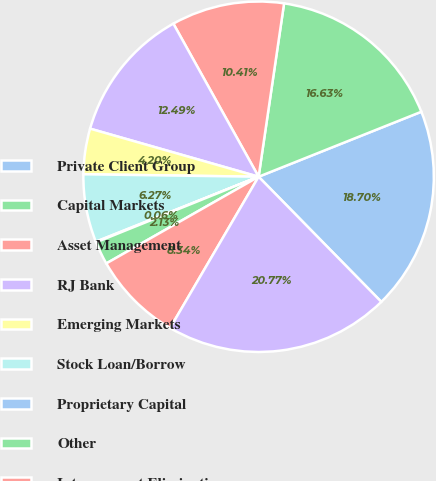<chart> <loc_0><loc_0><loc_500><loc_500><pie_chart><fcel>Private Client Group<fcel>Capital Markets<fcel>Asset Management<fcel>RJ Bank<fcel>Emerging Markets<fcel>Stock Loan/Borrow<fcel>Proprietary Capital<fcel>Other<fcel>Intersegment Eliminations<fcel>Total Revenues ^(1)<nl><fcel>18.7%<fcel>16.63%<fcel>10.41%<fcel>12.49%<fcel>4.2%<fcel>6.27%<fcel>0.06%<fcel>2.13%<fcel>8.34%<fcel>20.77%<nl></chart> 